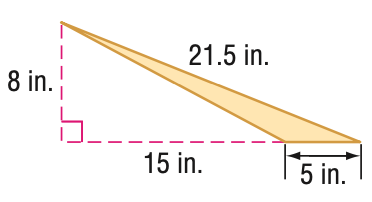Answer the mathemtical geometry problem and directly provide the correct option letter.
Question: Find the perimeter of the triangle. Round to the nearest tenth if necessary.
Choices: A: 43.0 B: 43.5 C: 48.0 D: 49.5 B 